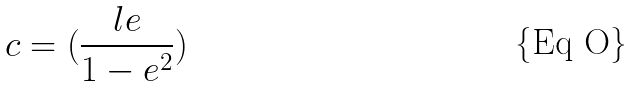<formula> <loc_0><loc_0><loc_500><loc_500>c = ( \frac { l e } { 1 - e ^ { 2 } } )</formula> 